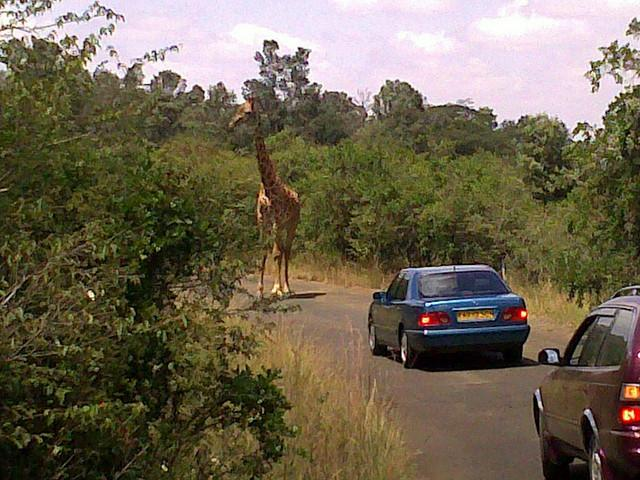What are you supposed to do when you meet an animal like this on the road? stop 